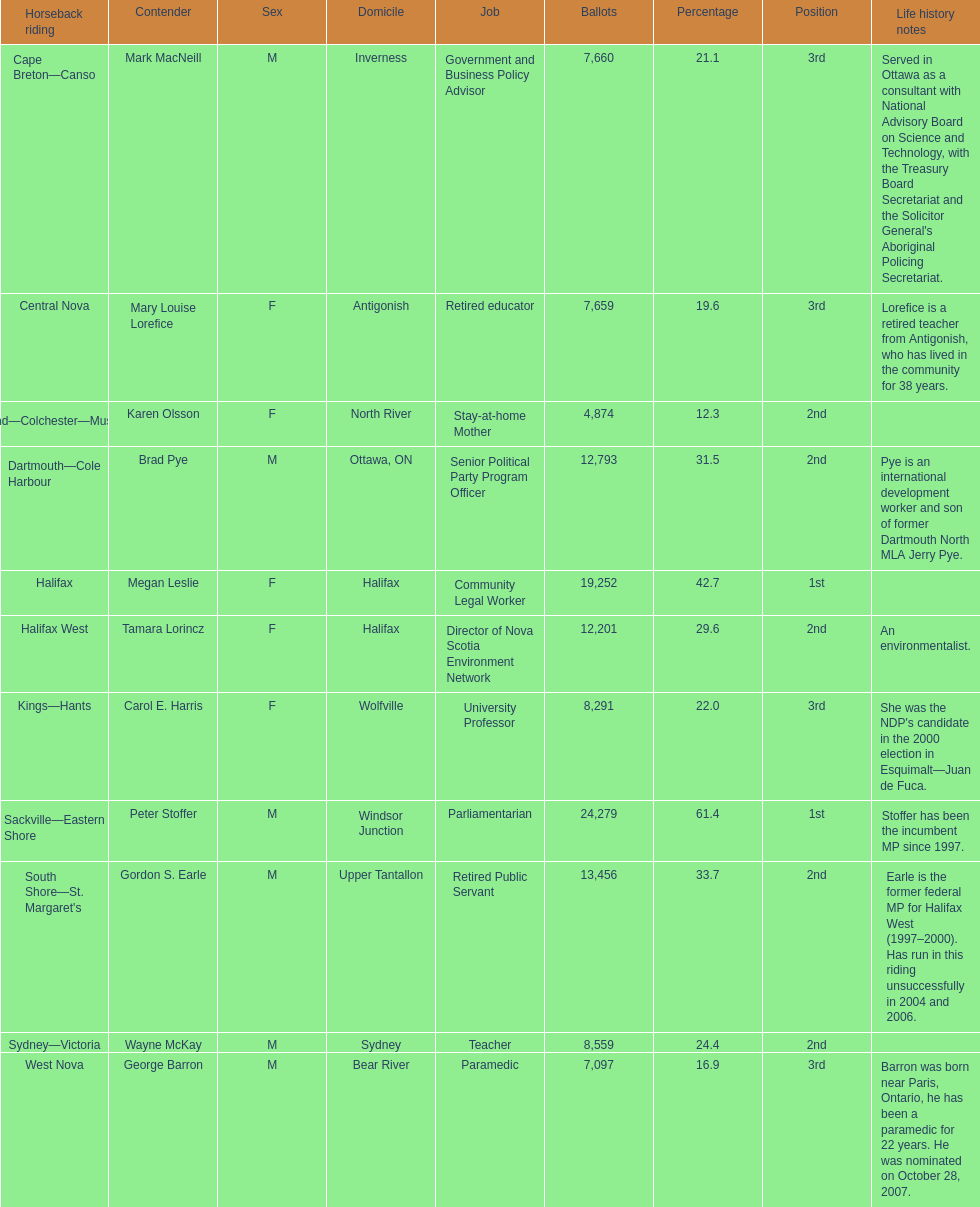What is the first riding? Cape Breton-Canso. 